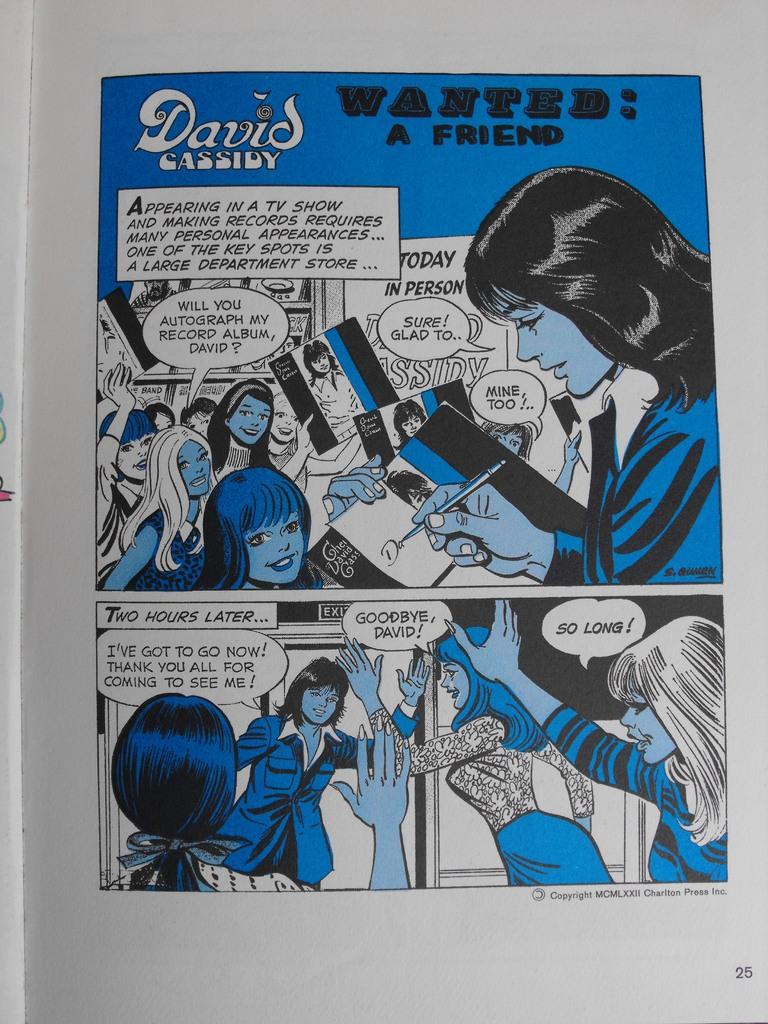What is the medium of the image? The image is on a paper. What can be seen in the images of people? The images of people show various individuals. What else is present in the image besides the images of people? There is text in the image. What type of weather is depicted in the image? There is no weather depicted in the image, as it consists of images of people and text on a paper. 